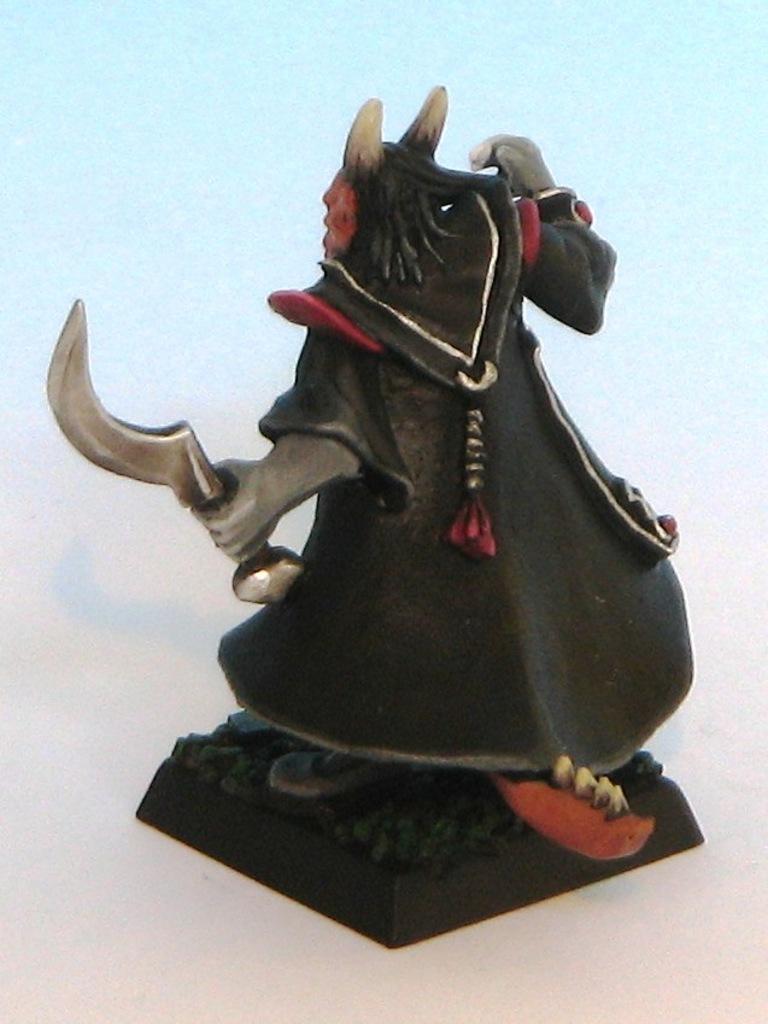In one or two sentences, can you explain what this image depicts? In this image we can see a sculpture on a platform. In the background the image is in light blue color. 